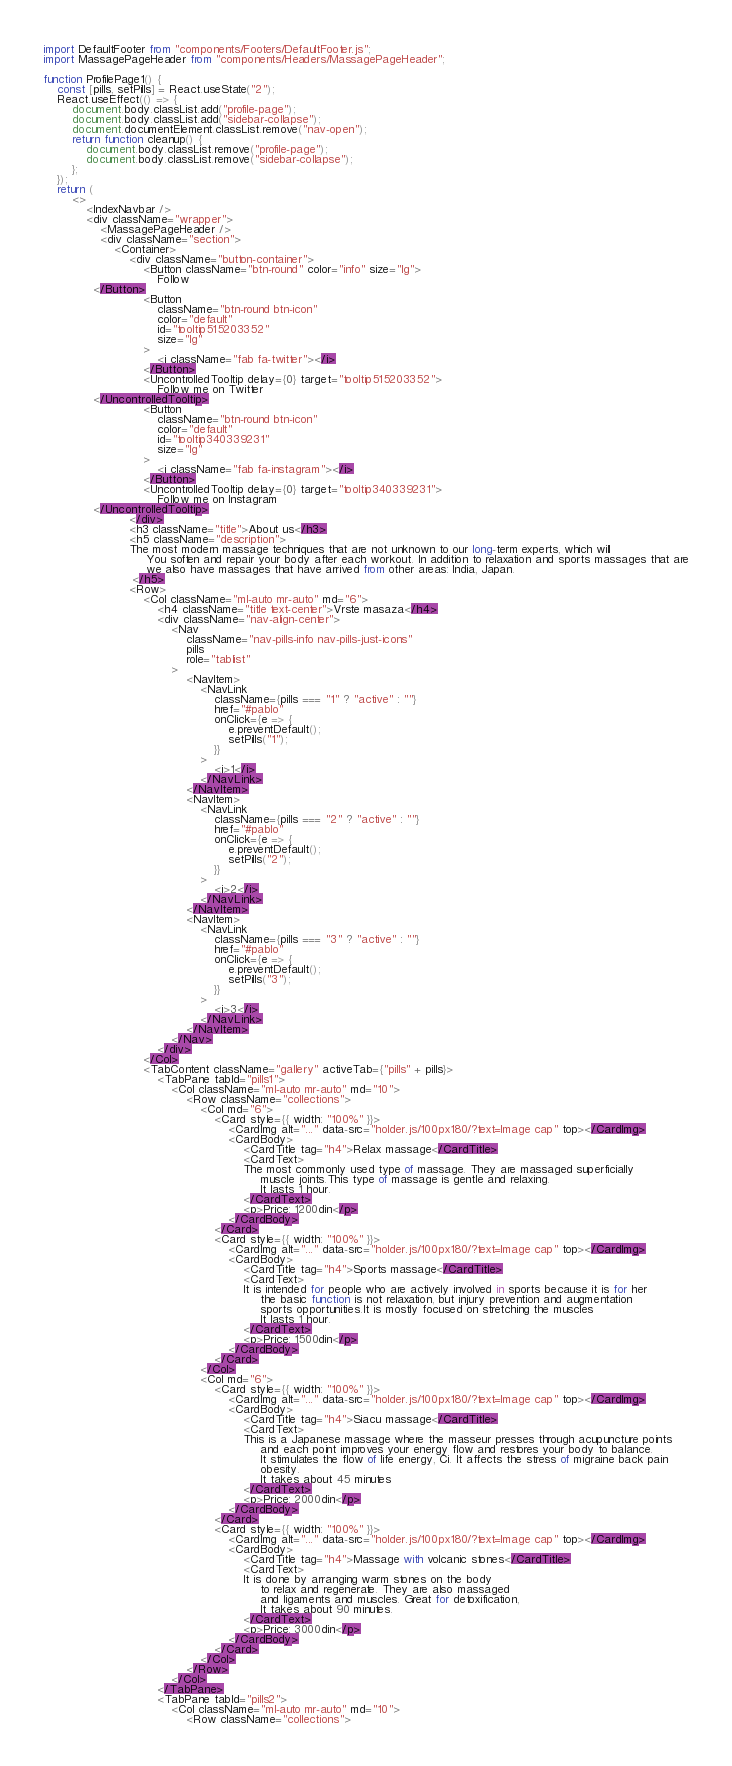Convert code to text. <code><loc_0><loc_0><loc_500><loc_500><_JavaScript_>import DefaultFooter from "components/Footers/DefaultFooter.js";
import MassagePageHeader from "components/Headers/MassagePageHeader";

function ProfilePage1() {
    const [pills, setPills] = React.useState("2");
    React.useEffect(() => {
        document.body.classList.add("profile-page");
        document.body.classList.add("sidebar-collapse");
        document.documentElement.classList.remove("nav-open");
        return function cleanup() {
            document.body.classList.remove("profile-page");
            document.body.classList.remove("sidebar-collapse");
        };
    });
    return (
        <>
            <IndexNavbar />
            <div className="wrapper">
                <MassagePageHeader />
                <div className="section">
                    <Container>
                        <div className="button-container">
                            <Button className="btn-round" color="info" size="lg">
                                Follow
              </Button>
                            <Button
                                className="btn-round btn-icon"
                                color="default"
                                id="tooltip515203352"
                                size="lg"
                            >
                                <i className="fab fa-twitter"></i>
                            </Button>
                            <UncontrolledTooltip delay={0} target="tooltip515203352">
                                Follow me on Twitter
              </UncontrolledTooltip>
                            <Button
                                className="btn-round btn-icon"
                                color="default"
                                id="tooltip340339231"
                                size="lg"
                            >
                                <i className="fab fa-instagram"></i>
                            </Button>
                            <UncontrolledTooltip delay={0} target="tooltip340339231">
                                Follow me on Instagram
              </UncontrolledTooltip>
                        </div>
                        <h3 className="title">About us</h3>
                        <h5 className="description">
                        The most modern massage techniques that are not unknown to our long-term experts, which will
                             You soften and repair your body after each workout. In addition to relaxation and sports massages that are
                             we also have massages that have arrived from other areas: India, Japan.
                         </h5>
                        <Row>
                            <Col className="ml-auto mr-auto" md="6">
                                <h4 className="title text-center">Vrste masaza</h4>
                                <div className="nav-align-center">
                                    <Nav
                                        className="nav-pills-info nav-pills-just-icons"
                                        pills
                                        role="tablist"
                                    >
                                        <NavItem>
                                            <NavLink
                                                className={pills === "1" ? "active" : ""}
                                                href="#pablo"
                                                onClick={e => {
                                                    e.preventDefault();
                                                    setPills("1");
                                                }}
                                            >
                                                <i>1</i>
                                            </NavLink>
                                        </NavItem>
                                        <NavItem>
                                            <NavLink
                                                className={pills === "2" ? "active" : ""}
                                                href="#pablo"
                                                onClick={e => {
                                                    e.preventDefault();
                                                    setPills("2");
                                                }}
                                            >
                                                <i>2</i>
                                            </NavLink>
                                        </NavItem>
                                        <NavItem>
                                            <NavLink
                                                className={pills === "3" ? "active" : ""}
                                                href="#pablo"
                                                onClick={e => {
                                                    e.preventDefault();
                                                    setPills("3");
                                                }}
                                            >
                                                <i>3</i>
                                            </NavLink>
                                        </NavItem>
                                    </Nav>
                                </div>
                            </Col>
                            <TabContent className="gallery" activeTab={"pills" + pills}>
                                <TabPane tabId="pills1">
                                    <Col className="ml-auto mr-auto" md="10">
                                        <Row className="collections">
                                            <Col md="6">
                                                <Card style={{ width: "100%" }}>
                                                    <CardImg alt="..." data-src="holder.js/100px180/?text=Image cap" top></CardImg>
                                                    <CardBody>
                                                        <CardTitle tag="h4">Relax massage</CardTitle>
                                                        <CardText>
                                                        The most commonly used type of massage. They are massaged superficially
                                                             muscle joints.This type of massage is gentle and relaxing.
                                                             It lasts 1 hour.
                                                        </CardText>
                                                        <p>Price: 1200din</p>
                                                    </CardBody>
                                                </Card>
                                                <Card style={{ width: "100%" }}>
                                                    <CardImg alt="..." data-src="holder.js/100px180/?text=Image cap" top></CardImg>
                                                    <CardBody>
                                                        <CardTitle tag="h4">Sports massage</CardTitle>
                                                        <CardText>
                                                        It is intended for people who are actively involved in sports because it is for her
                                                             the basic function is not relaxation, but injury prevention and augmentation
                                                             sports opportunities.It is mostly focused on stretching the muscles
                                                             It lasts 1 hour.
                                                        </CardText>
                                                        <p>Price: 1500din</p>
                                                    </CardBody>
                                                </Card>
                                            </Col>
                                            <Col md="6">
                                                <Card style={{ width: "100%" }}>
                                                    <CardImg alt="..." data-src="holder.js/100px180/?text=Image cap" top></CardImg>
                                                    <CardBody>
                                                        <CardTitle tag="h4">Siacu massage</CardTitle>
                                                        <CardText>
                                                        This is a Japanese massage where the masseur presses through acupuncture points
                                                             and each point improves your energy flow and restores your body to balance.
                                                             It stimulates the flow of life energy, Ci. It affects the stress of migraine back pain
                                                             obesity.
                                                             It takes about 45 minutes
                                                        </CardText>
                                                        <p>Price: 2000din</p>
                                                    </CardBody>
                                                </Card>
                                                <Card style={{ width: "100%" }}>
                                                    <CardImg alt="..." data-src="holder.js/100px180/?text=Image cap" top></CardImg>
                                                    <CardBody>
                                                        <CardTitle tag="h4">Massage with volcanic stones</CardTitle>
                                                        <CardText>
                                                        It is done by arranging warm stones on the body
                                                             to relax and regenerate. They are also massaged
                                                             and ligaments and muscles. Great for detoxification,
                                                             It takes about 90 minutes.
                                                        </CardText>
                                                        <p>Price: 3000din</p>
                                                    </CardBody>
                                                </Card>
                                            </Col>
                                        </Row>
                                    </Col>
                                </TabPane>
                                <TabPane tabId="pills2">
                                    <Col className="ml-auto mr-auto" md="10">
                                        <Row className="collections"></code> 